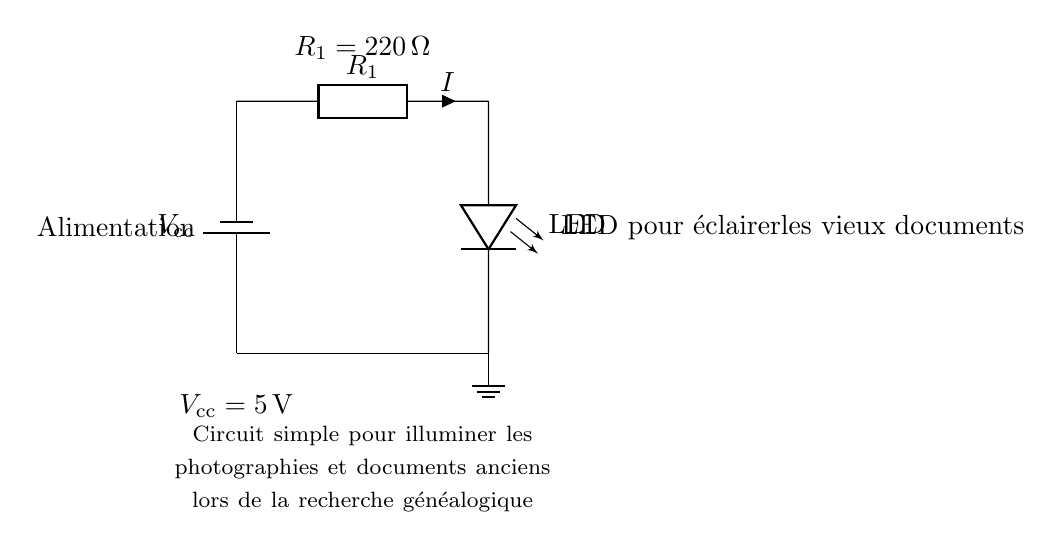What is the power supply voltage in this circuit? The voltage supplied by the battery in this circuit is labeled as Vcc, and is specifically indicated to be 5 volts.
Answer: 5 volts What is the purpose of the resistor in this circuit? The resistor, R1, is used to limit the current flowing through the LED to prevent it from drawing too much current, which could damage the LED.
Answer: Current limiting What is the value of the resistor R1? The diagram provides a direct label for the resistor R1, indicating it has a value of 220 ohms.
Answer: 220 ohms How many major components are shown in this circuit? The circuit contains three major components: the battery, the resistor, and the LED. This includes the connections but focuses on distinct components.
Answer: Three What type of circuit is represented here? The circuit is a basic LED circuit designed for illuminating photographs and documents, which makes it specific in its application.
Answer: Basic LED circuit What happens if the current flowing through the LED exceeds its rating? If the current flowing through the LED exceeds its rated maximum, it can cause the LED to become damaged or burnt out due to overheating.
Answer: Damage to LED Why is the LED labeled in the schematic diagram? The LED is labeled to indicate its function within the circuit, specifically its purpose in the context of illuminating documents, which is crucial for understanding the circuit's application.
Answer: For illumination 